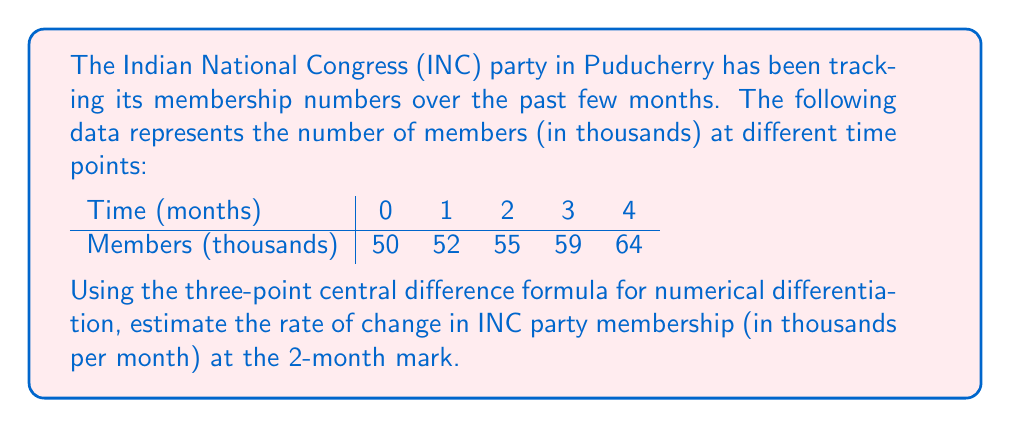Help me with this question. To solve this problem, we'll use the three-point central difference formula for numerical differentiation:

$$f'(x) \approx \frac{f(x+h) - f(x-h)}{2h}$$

Where:
$f(x)$ is the function (party membership)
$h$ is the step size (1 month in this case)
$x$ is the point at which we're estimating the derivative (2 months)

Step 1: Identify the relevant data points
At $x = 2$ months:
$f(x-h) = f(1) = 52$
$f(x) = f(2) = 55$
$f(x+h) = f(3) = 59$

Step 2: Apply the three-point central difference formula
$$f'(2) \approx \frac{f(3) - f(1)}{2(1)}$$

Step 3: Substitute the values
$$f'(2) \approx \frac{59 - 52}{2(1)} = \frac{7}{2} = 3.5$$

Therefore, the estimated rate of change in INC party membership at the 2-month mark is 3.5 thousand members per month.
Answer: 3.5 thousand members/month 